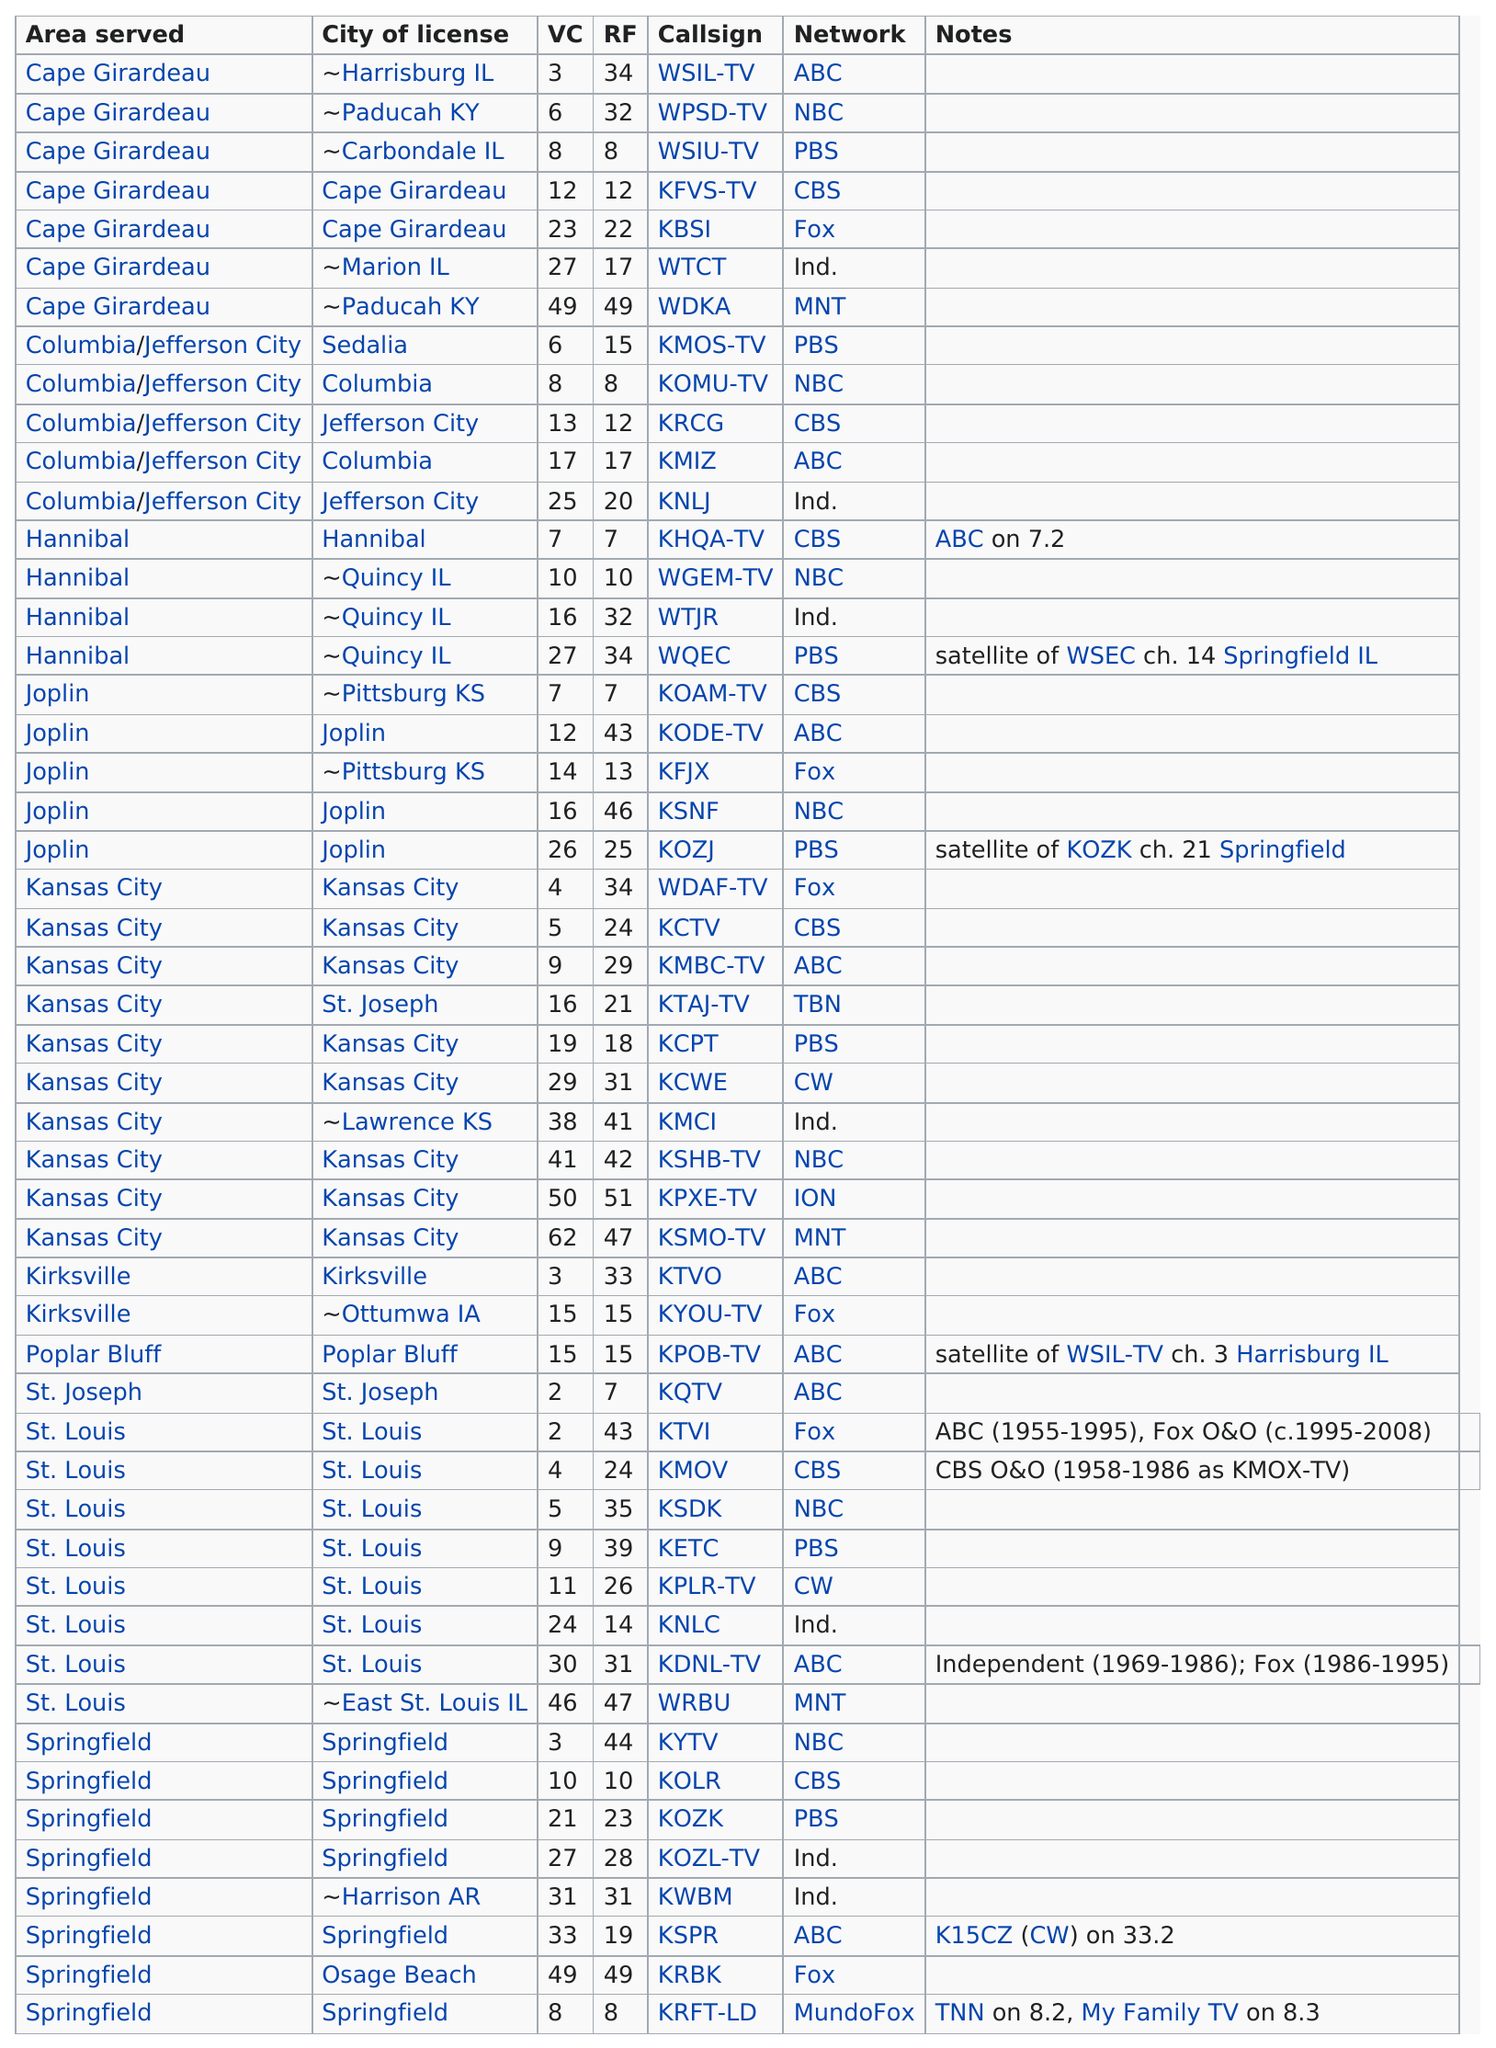Draw attention to some important aspects in this diagram. Seven are currently on the CBS network. Kansas City has the most stations serving it out of all areas. Seven of the Missouri television stations are licensed in a city in Illinois, but it is unclear if they are actually broadcasting from that location. The total number of stations under the CBS network is 7. Both kode-tv and wsil-tv are part of the same network, which is known as ABC. 